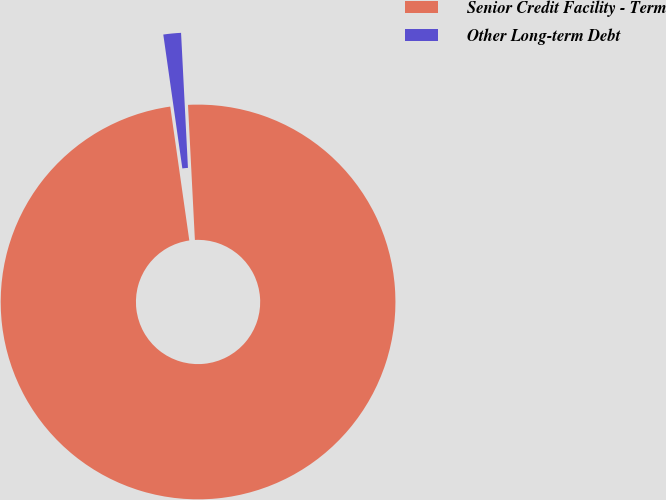Convert chart. <chart><loc_0><loc_0><loc_500><loc_500><pie_chart><fcel>Senior Credit Facility - Term<fcel>Other Long-term Debt<nl><fcel>98.56%<fcel>1.44%<nl></chart> 